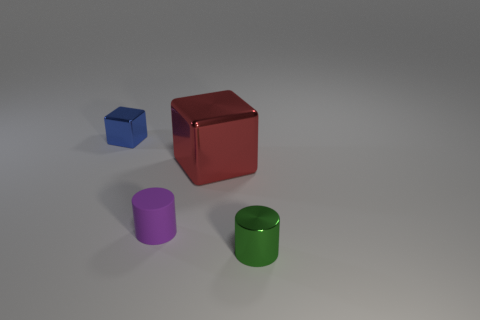Add 2 big metal cubes. How many objects exist? 6 Add 1 purple cylinders. How many purple cylinders are left? 2 Add 4 rubber objects. How many rubber objects exist? 5 Subtract 0 yellow blocks. How many objects are left? 4 Subtract all tiny shiny cylinders. Subtract all small green objects. How many objects are left? 2 